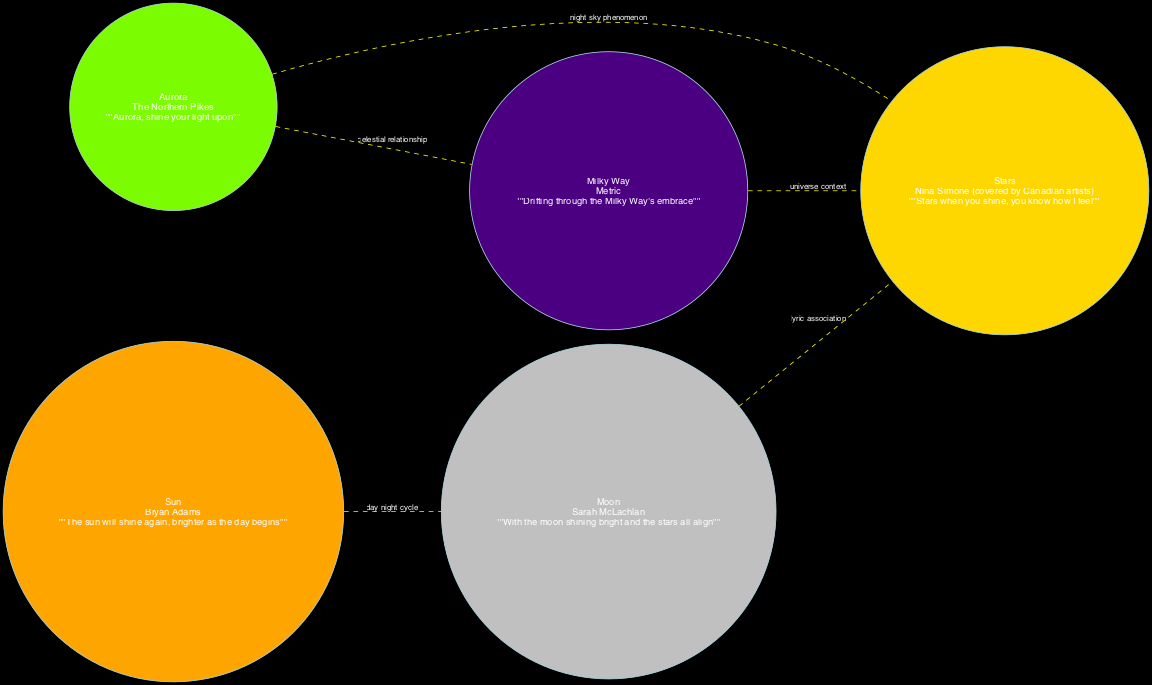What is the lyric snippet from Sarah McLachlan's song? The diagram shows the node for "Moon," which includes the lyric snippet, specifically mentioning Sarah McLachlan's song "Building a Mystery." The snippet reads, "With the moon shining bright and the stars all align."
Answer: "With the moon shining bright and the stars all align" How many celestial bodies are represented in the diagram? The diagram includes five distinct nodes: Moon, Stars, Aurora, Sun, and Milky Way. Counting them gives a total of five celestial bodies.
Answer: 5 Which artist is associated with the lyric about Aurora? The diagram identifies the node for "Aurora" and states that it is associated with the artist The Northern Pikes, featured in their song "Hopes Go Astray."
Answer: The Northern Pikes Which celestial body is connected to the Moon by a day-night cycle? The diagram indicates that the Sun connects to the Moon in the context of the day-night cycle. This connection suggests a relationship where the Sun governs the daylight while the Moon is visible at night.
Answer: Sun What type of relationship connects Aurora and Milky Way? The diagram categorizes the relationship between Aurora and Milky Way as a "celestial relationship," illustrating how they are related in the context of celestial bodies referenced in songs.
Answer: celestial relationship What lyric is associated with the Milky Way and which artist performed it? The diagram shows that Metric is the artist connected to the Milky Way, with the lyric snippet stating, "Drifting through the Milky Way's embrace." This reveals both the artist and the associated lyric directly linked to the Milky Way node.
Answer: "Drifting through the Milky Way's embrace" - Metric Which celestial body is associated with the night sky phenomenon alongside Stars? The diagram demonstrates that the Aurora is linked to Stars in the context of a "night sky phenomenon," indicating both celestial bodies share a representation in this regard.
Answer: Aurora What is the total number of connections between the celestial bodies? The diagram lists a total of five edges representing connections between celestial bodies, accounting for various relationships described. Counting these gives three significant types of connections that contribute to the overall count.
Answer: 5 